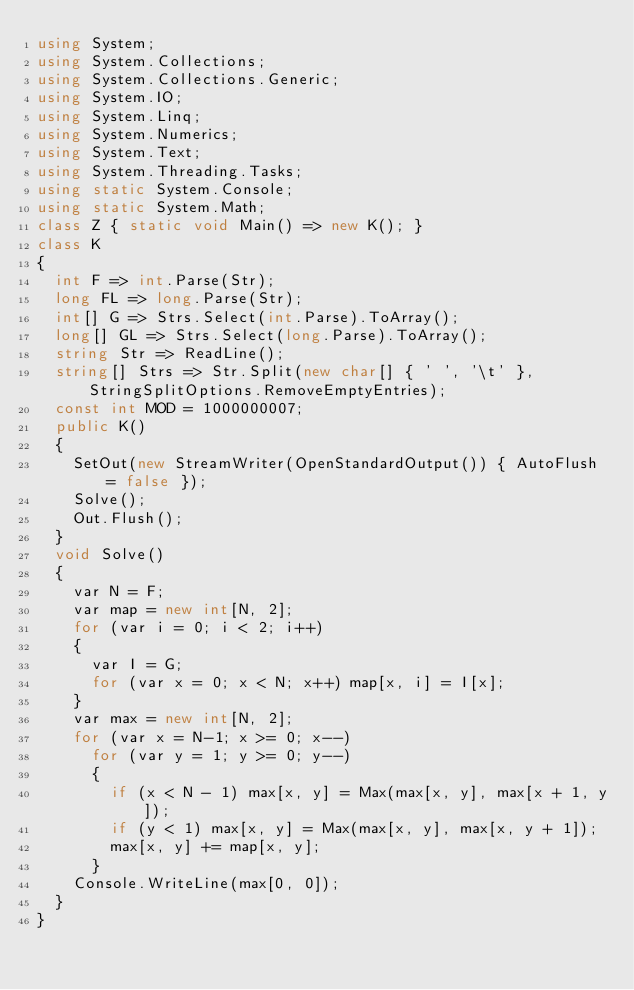Convert code to text. <code><loc_0><loc_0><loc_500><loc_500><_C#_>using System;
using System.Collections;
using System.Collections.Generic;
using System.IO;
using System.Linq;
using System.Numerics;
using System.Text;
using System.Threading.Tasks;
using static System.Console;
using static System.Math;
class Z { static void Main() => new K(); }
class K
{
	int F => int.Parse(Str);
	long FL => long.Parse(Str);
	int[] G => Strs.Select(int.Parse).ToArray();
	long[] GL => Strs.Select(long.Parse).ToArray();
	string Str => ReadLine();
	string[] Strs => Str.Split(new char[] { ' ', '\t' }, StringSplitOptions.RemoveEmptyEntries);
	const int MOD = 1000000007;
	public K()
	{
		SetOut(new StreamWriter(OpenStandardOutput()) { AutoFlush = false });
		Solve();
		Out.Flush();
	}
	void Solve()
	{
		var N = F;
		var map = new int[N, 2];
		for (var i = 0; i < 2; i++)
		{
			var I = G;
			for (var x = 0; x < N; x++) map[x, i] = I[x];
		}
		var max = new int[N, 2];
		for (var x = N-1; x >= 0; x--)
			for (var y = 1; y >= 0; y--)
			{
				if (x < N - 1) max[x, y] = Max(max[x, y], max[x + 1, y]);
				if (y < 1) max[x, y] = Max(max[x, y], max[x, y + 1]);
				max[x, y] += map[x, y];
			}
		Console.WriteLine(max[0, 0]);
	}
}
</code> 